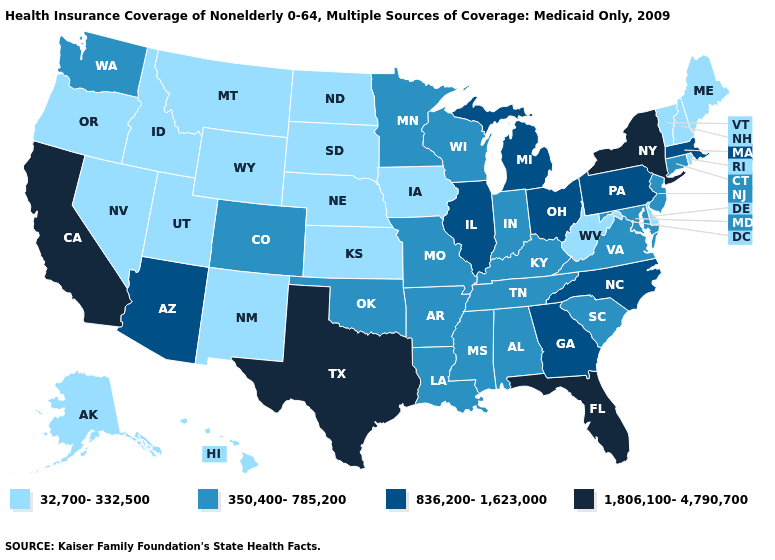What is the highest value in states that border Iowa?
Short answer required. 836,200-1,623,000. Name the states that have a value in the range 32,700-332,500?
Answer briefly. Alaska, Delaware, Hawaii, Idaho, Iowa, Kansas, Maine, Montana, Nebraska, Nevada, New Hampshire, New Mexico, North Dakota, Oregon, Rhode Island, South Dakota, Utah, Vermont, West Virginia, Wyoming. Name the states that have a value in the range 1,806,100-4,790,700?
Keep it brief. California, Florida, New York, Texas. How many symbols are there in the legend?
Write a very short answer. 4. Name the states that have a value in the range 1,806,100-4,790,700?
Give a very brief answer. California, Florida, New York, Texas. How many symbols are there in the legend?
Answer briefly. 4. What is the lowest value in states that border Rhode Island?
Short answer required. 350,400-785,200. What is the highest value in states that border New York?
Write a very short answer. 836,200-1,623,000. What is the highest value in the USA?
Short answer required. 1,806,100-4,790,700. Which states have the highest value in the USA?
Short answer required. California, Florida, New York, Texas. Does New York have the highest value in the USA?
Quick response, please. Yes. Name the states that have a value in the range 1,806,100-4,790,700?
Answer briefly. California, Florida, New York, Texas. Is the legend a continuous bar?
Keep it brief. No. Name the states that have a value in the range 1,806,100-4,790,700?
Be succinct. California, Florida, New York, Texas. Name the states that have a value in the range 32,700-332,500?
Write a very short answer. Alaska, Delaware, Hawaii, Idaho, Iowa, Kansas, Maine, Montana, Nebraska, Nevada, New Hampshire, New Mexico, North Dakota, Oregon, Rhode Island, South Dakota, Utah, Vermont, West Virginia, Wyoming. 